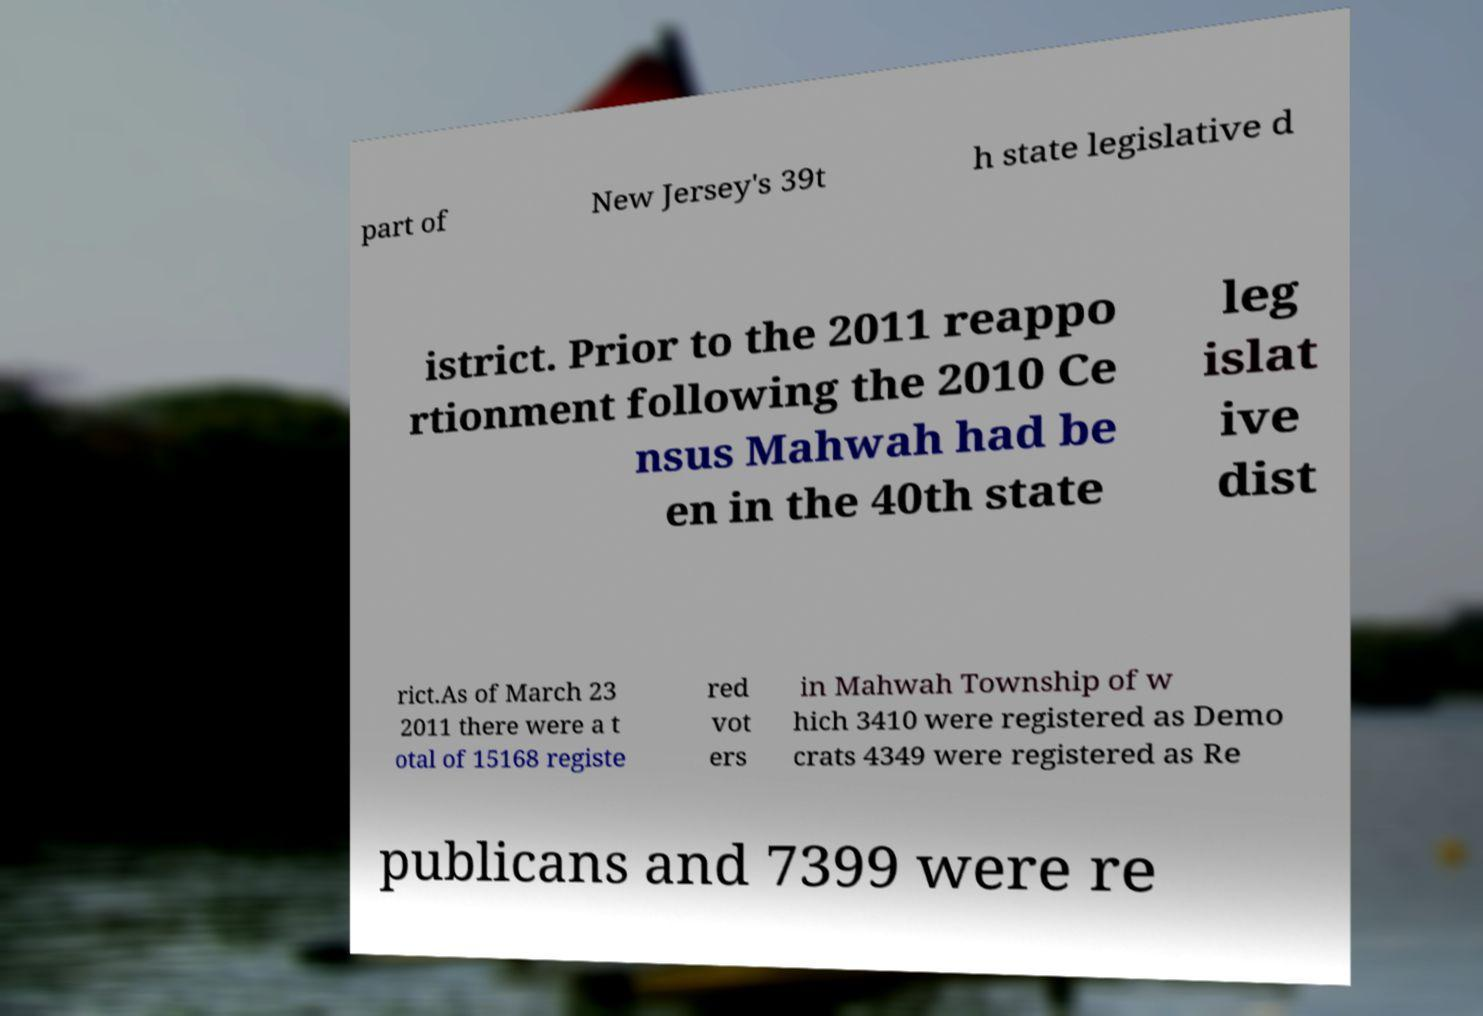I need the written content from this picture converted into text. Can you do that? part of New Jersey's 39t h state legislative d istrict. Prior to the 2011 reappo rtionment following the 2010 Ce nsus Mahwah had be en in the 40th state leg islat ive dist rict.As of March 23 2011 there were a t otal of 15168 registe red vot ers in Mahwah Township of w hich 3410 were registered as Demo crats 4349 were registered as Re publicans and 7399 were re 